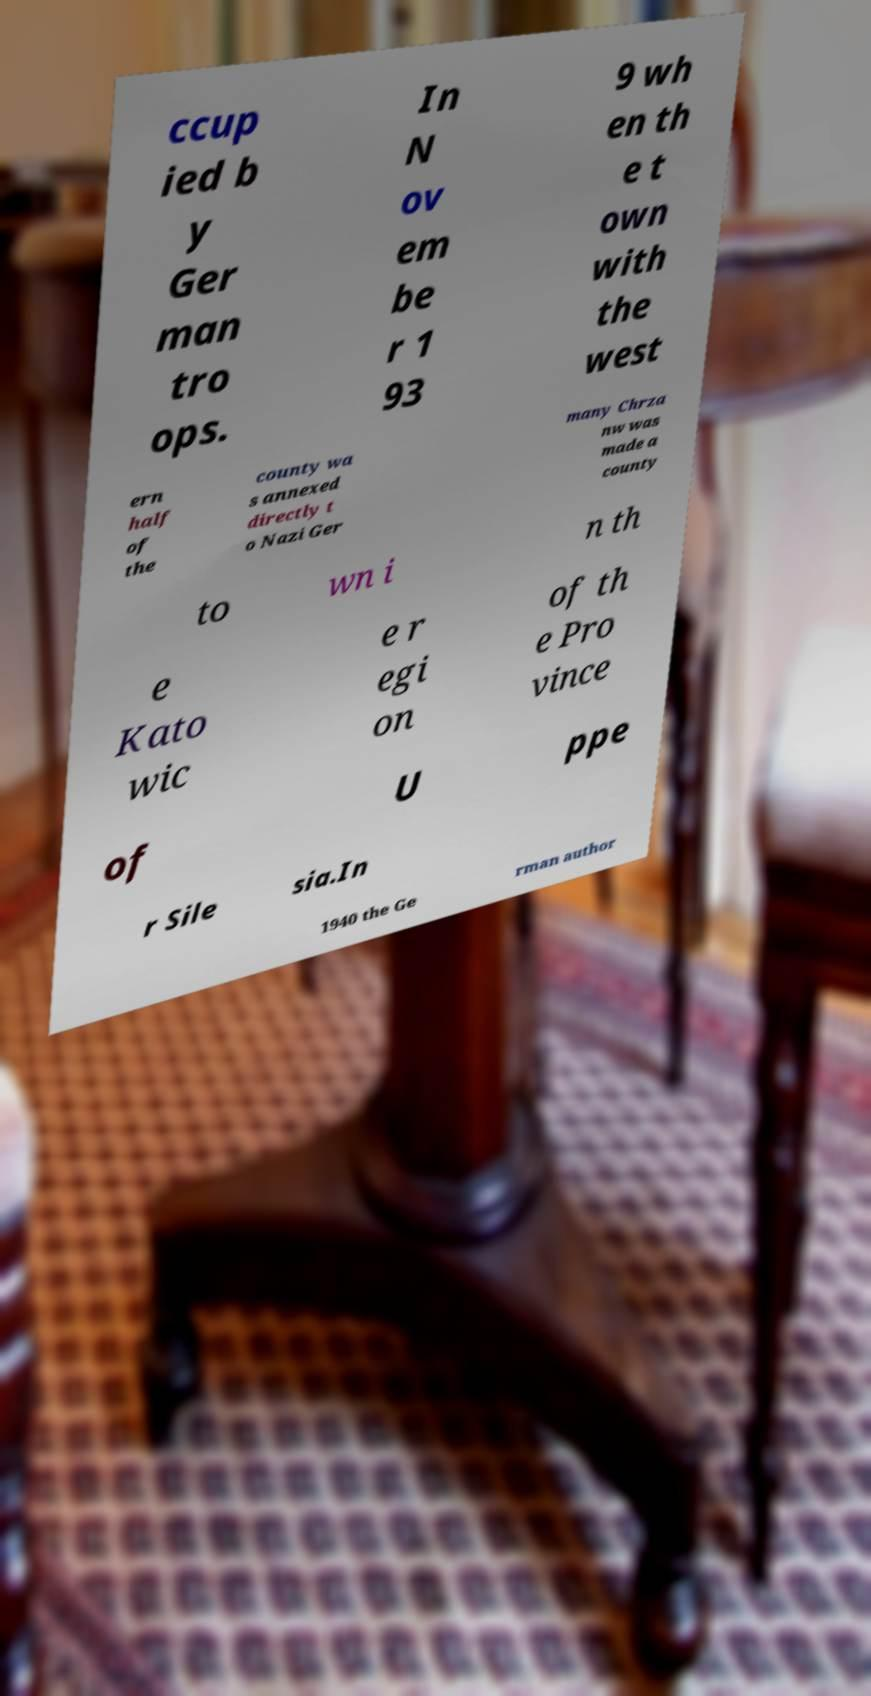Please read and relay the text visible in this image. What does it say? ccup ied b y Ger man tro ops. In N ov em be r 1 93 9 wh en th e t own with the west ern half of the county wa s annexed directly t o Nazi Ger many Chrza nw was made a county to wn i n th e Kato wic e r egi on of th e Pro vince of U ppe r Sile sia.In 1940 the Ge rman author 